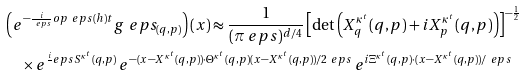<formula> <loc_0><loc_0><loc_500><loc_500>& \left ( e ^ { - \frac { i } { \ e p s } o p ^ { \ } e p s ( h ) t } g ^ { \ } e p s _ { ( q , p ) } \right ) ( x ) \approx \frac { 1 } { ( \pi \ e p s ) ^ { d / 4 } } \left [ \det \left ( X _ { q } ^ { \kappa ^ { t } } ( q , p ) + i X _ { p } ^ { \kappa ^ { t } } ( q , p ) \right ) \right ] ^ { - \frac { 1 } { 2 } } \\ & \quad \times e ^ { \frac { i } \ e p s S ^ { \kappa ^ { t } } ( q , p ) } \, e ^ { - ( x - X ^ { \kappa ^ { t } } ( q , p ) ) \cdot \Theta ^ { \kappa ^ { t } } ( q , p ) ( x - X ^ { \kappa ^ { t } } ( q , p ) ) / 2 \ e p s } \, e ^ { i \Xi ^ { \kappa ^ { t } } ( q , p ) \cdot ( x - X ^ { \kappa ^ { t } } ( q , p ) ) / \ e p s }</formula> 